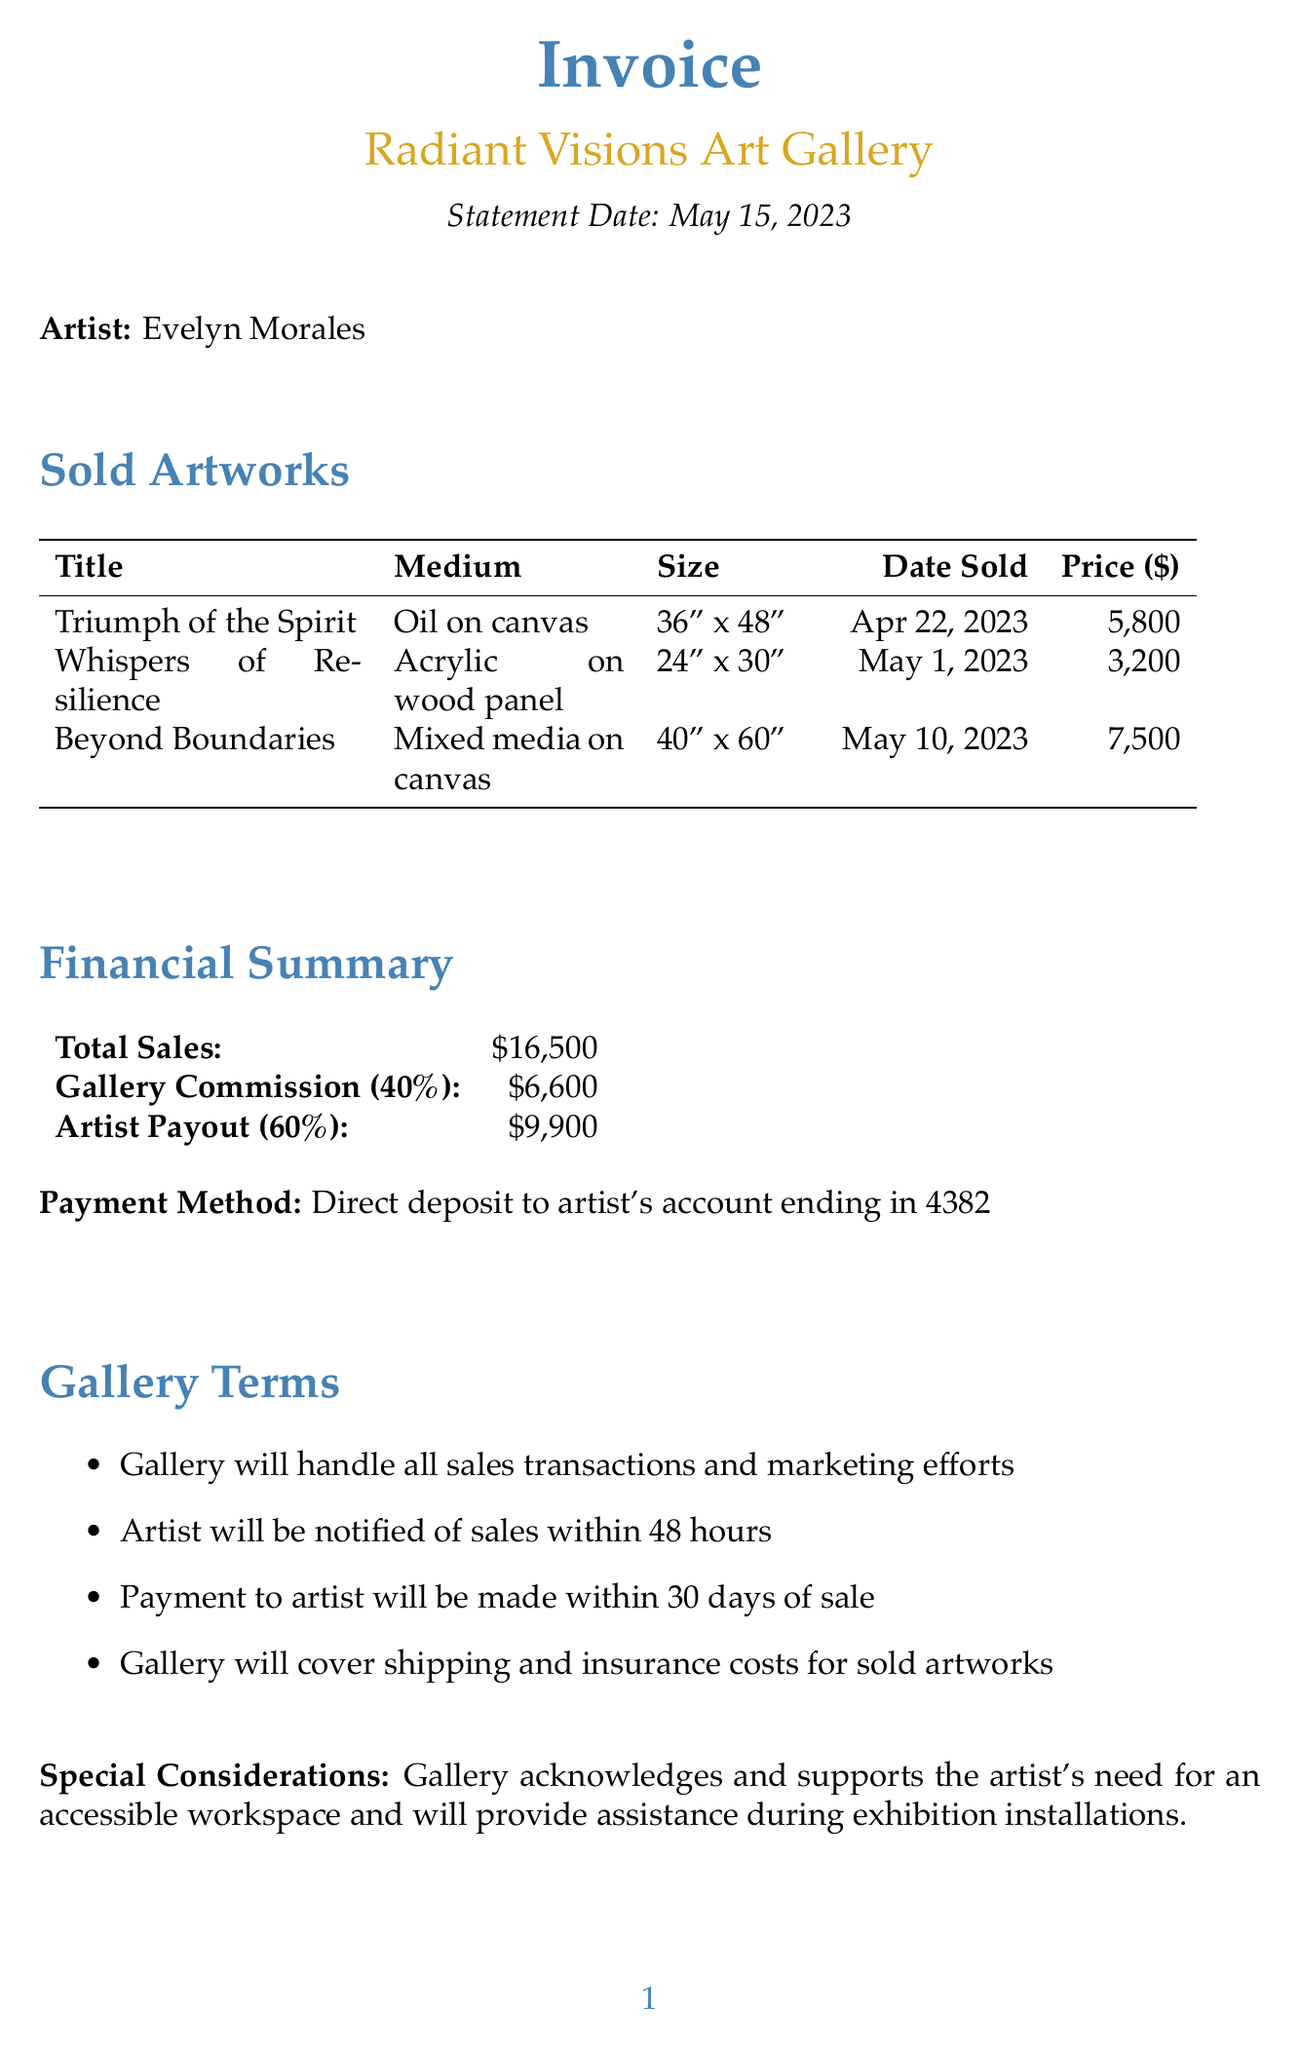What is the name of the gallery? The gallery is identified at the beginning of the document as Radiant Visions Art Gallery.
Answer: Radiant Visions Art Gallery What is the sale price of "Beyond Boundaries"? The sale price of "Beyond Boundaries" is listed in the sold artworks section of the document.
Answer: 7500 When was "Whispers of Resilience" sold? The date of sale for "Whispers of Resilience" is included in the table of sold artworks.
Answer: May 1, 2023 What is the gallery's commission percentage? The commission percentage is detailed in the financial summary section of the document.
Answer: 40 What is the total amount the artist will receive? The artist payout is specified in the financial summary section of the document.
Answer: 9900 How many pieces are required for the upcoming exhibition? The number of pieces required is mentioned under the upcoming exhibition section.
Answer: 15 What payment method will be used? The payment method is stated clearly in the financial summary section of the document.
Answer: Direct deposit to artist's account ending in 4382 What type of medium was used for "Triumph of the Spirit"? The medium for "Triumph of the Spirit" is included in the sold artworks table.
Answer: Oil on canvas What special consideration is mentioned regarding accessibility? The special consideration regarding accessibility is highlighted in the gallery terms section.
Answer: Accessible workspace support 